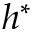Convert formula to latex. <formula><loc_0><loc_0><loc_500><loc_500>h ^ { * }</formula> 